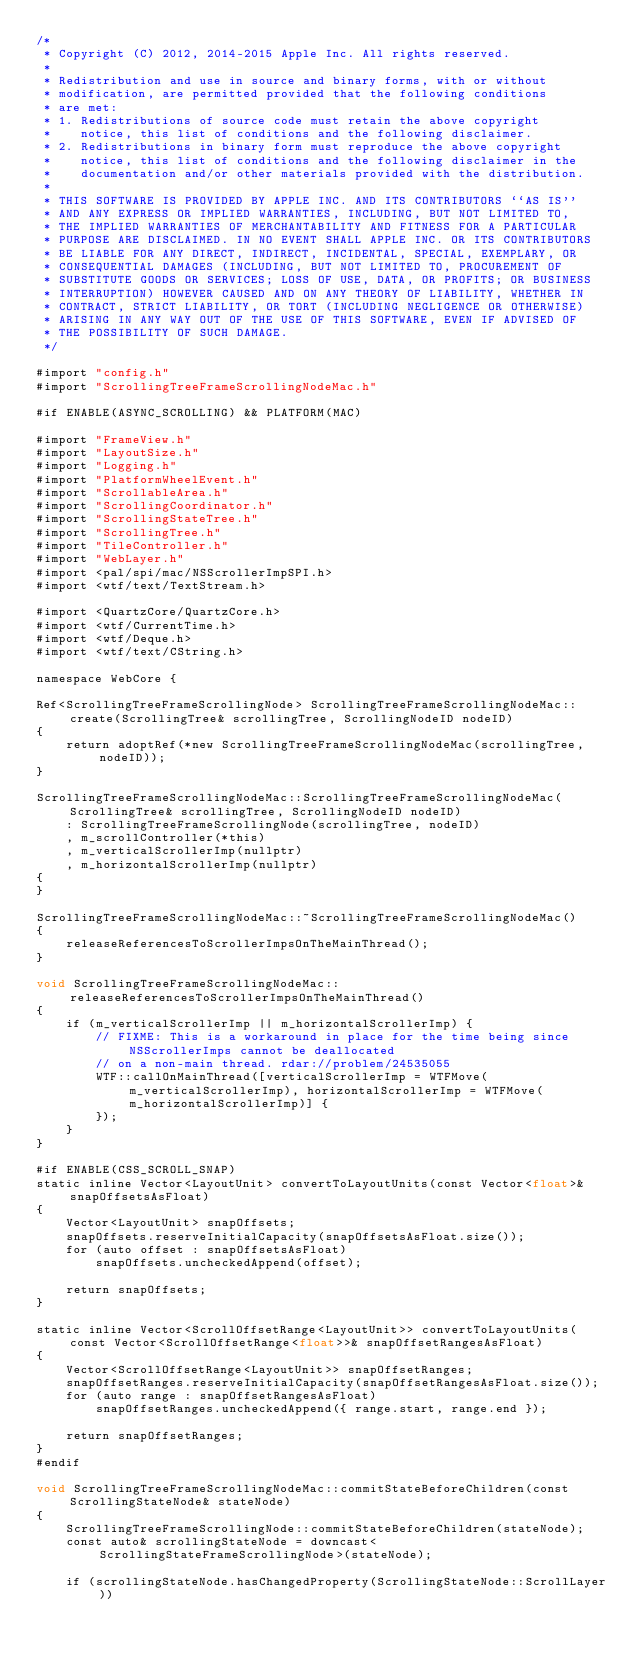Convert code to text. <code><loc_0><loc_0><loc_500><loc_500><_ObjectiveC_>/*
 * Copyright (C) 2012, 2014-2015 Apple Inc. All rights reserved.
 *
 * Redistribution and use in source and binary forms, with or without
 * modification, are permitted provided that the following conditions
 * are met:
 * 1. Redistributions of source code must retain the above copyright
 *    notice, this list of conditions and the following disclaimer.
 * 2. Redistributions in binary form must reproduce the above copyright
 *    notice, this list of conditions and the following disclaimer in the
 *    documentation and/or other materials provided with the distribution.
 *
 * THIS SOFTWARE IS PROVIDED BY APPLE INC. AND ITS CONTRIBUTORS ``AS IS''
 * AND ANY EXPRESS OR IMPLIED WARRANTIES, INCLUDING, BUT NOT LIMITED TO,
 * THE IMPLIED WARRANTIES OF MERCHANTABILITY AND FITNESS FOR A PARTICULAR
 * PURPOSE ARE DISCLAIMED. IN NO EVENT SHALL APPLE INC. OR ITS CONTRIBUTORS
 * BE LIABLE FOR ANY DIRECT, INDIRECT, INCIDENTAL, SPECIAL, EXEMPLARY, OR
 * CONSEQUENTIAL DAMAGES (INCLUDING, BUT NOT LIMITED TO, PROCUREMENT OF
 * SUBSTITUTE GOODS OR SERVICES; LOSS OF USE, DATA, OR PROFITS; OR BUSINESS
 * INTERRUPTION) HOWEVER CAUSED AND ON ANY THEORY OF LIABILITY, WHETHER IN
 * CONTRACT, STRICT LIABILITY, OR TORT (INCLUDING NEGLIGENCE OR OTHERWISE)
 * ARISING IN ANY WAY OUT OF THE USE OF THIS SOFTWARE, EVEN IF ADVISED OF
 * THE POSSIBILITY OF SUCH DAMAGE.
 */

#import "config.h"
#import "ScrollingTreeFrameScrollingNodeMac.h"

#if ENABLE(ASYNC_SCROLLING) && PLATFORM(MAC)

#import "FrameView.h"
#import "LayoutSize.h"
#import "Logging.h"
#import "PlatformWheelEvent.h"
#import "ScrollableArea.h"
#import "ScrollingCoordinator.h"
#import "ScrollingStateTree.h"
#import "ScrollingTree.h"
#import "TileController.h"
#import "WebLayer.h"
#import <pal/spi/mac/NSScrollerImpSPI.h>
#import <wtf/text/TextStream.h>

#import <QuartzCore/QuartzCore.h>
#import <wtf/CurrentTime.h>
#import <wtf/Deque.h>
#import <wtf/text/CString.h>

namespace WebCore {

Ref<ScrollingTreeFrameScrollingNode> ScrollingTreeFrameScrollingNodeMac::create(ScrollingTree& scrollingTree, ScrollingNodeID nodeID)
{
    return adoptRef(*new ScrollingTreeFrameScrollingNodeMac(scrollingTree, nodeID));
}

ScrollingTreeFrameScrollingNodeMac::ScrollingTreeFrameScrollingNodeMac(ScrollingTree& scrollingTree, ScrollingNodeID nodeID)
    : ScrollingTreeFrameScrollingNode(scrollingTree, nodeID)
    , m_scrollController(*this)
    , m_verticalScrollerImp(nullptr)
    , m_horizontalScrollerImp(nullptr)
{
}

ScrollingTreeFrameScrollingNodeMac::~ScrollingTreeFrameScrollingNodeMac()
{
    releaseReferencesToScrollerImpsOnTheMainThread();
}

void ScrollingTreeFrameScrollingNodeMac::releaseReferencesToScrollerImpsOnTheMainThread()
{
    if (m_verticalScrollerImp || m_horizontalScrollerImp) {
        // FIXME: This is a workaround in place for the time being since NSScrollerImps cannot be deallocated
        // on a non-main thread. rdar://problem/24535055
        WTF::callOnMainThread([verticalScrollerImp = WTFMove(m_verticalScrollerImp), horizontalScrollerImp = WTFMove(m_horizontalScrollerImp)] {
        });
    }
}

#if ENABLE(CSS_SCROLL_SNAP)
static inline Vector<LayoutUnit> convertToLayoutUnits(const Vector<float>& snapOffsetsAsFloat)
{
    Vector<LayoutUnit> snapOffsets;
    snapOffsets.reserveInitialCapacity(snapOffsetsAsFloat.size());
    for (auto offset : snapOffsetsAsFloat)
        snapOffsets.uncheckedAppend(offset);

    return snapOffsets;
}

static inline Vector<ScrollOffsetRange<LayoutUnit>> convertToLayoutUnits(const Vector<ScrollOffsetRange<float>>& snapOffsetRangesAsFloat)
{
    Vector<ScrollOffsetRange<LayoutUnit>> snapOffsetRanges;
    snapOffsetRanges.reserveInitialCapacity(snapOffsetRangesAsFloat.size());
    for (auto range : snapOffsetRangesAsFloat)
        snapOffsetRanges.uncheckedAppend({ range.start, range.end });

    return snapOffsetRanges;
}
#endif

void ScrollingTreeFrameScrollingNodeMac::commitStateBeforeChildren(const ScrollingStateNode& stateNode)
{
    ScrollingTreeFrameScrollingNode::commitStateBeforeChildren(stateNode);
    const auto& scrollingStateNode = downcast<ScrollingStateFrameScrollingNode>(stateNode);

    if (scrollingStateNode.hasChangedProperty(ScrollingStateNode::ScrollLayer))</code> 